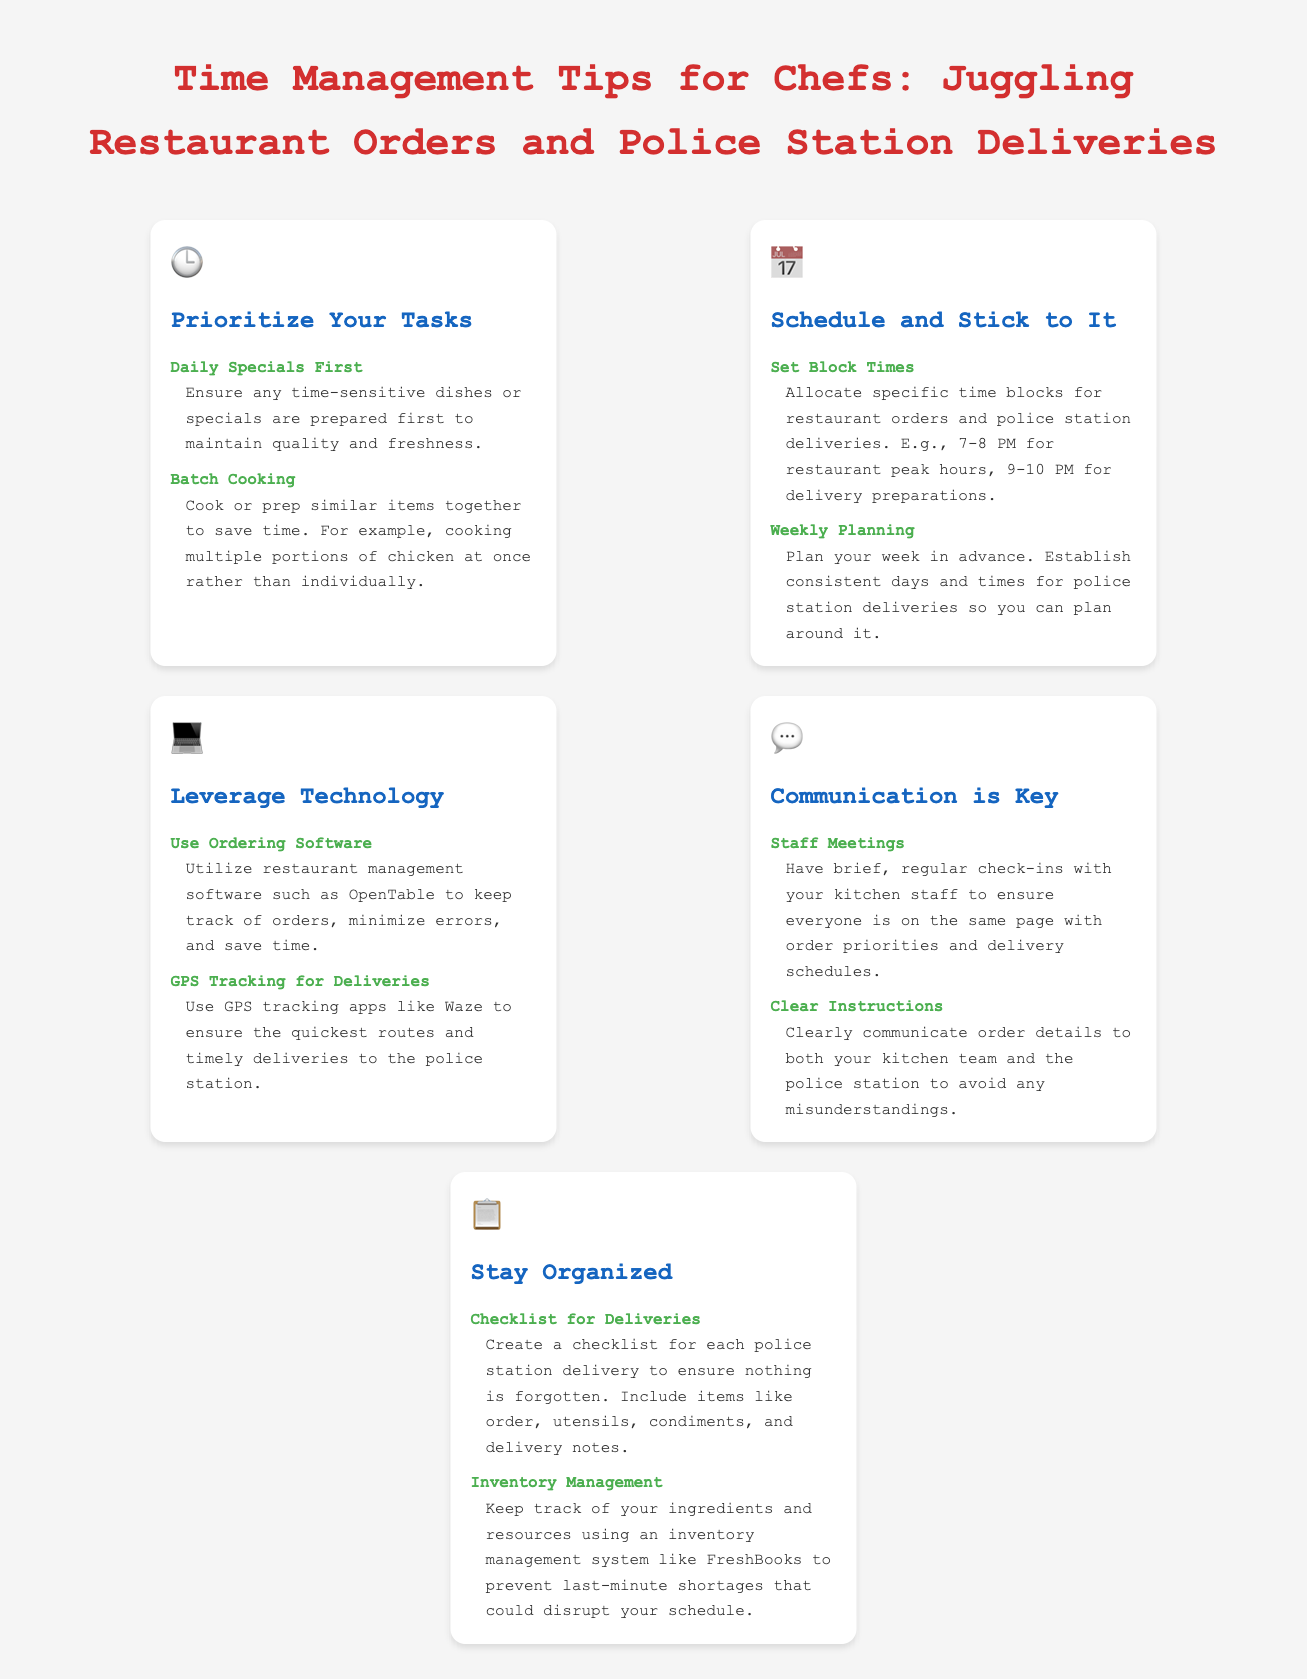what is the first priority for chefs when managing tasks? The first priority is to prepare any time-sensitive dishes or specials first to maintain quality and freshness.
Answer: Daily Specials First what technology should chefs use for managing orders? The document mentions utilizing restaurant management software for tracking orders.
Answer: Ordering Software what time block is suggested for restaurant peak hours? The suggested time block for restaurant peak hours is provided in the document.
Answer: 7-8 PM what should chefs create for each police station delivery? Chefs should create a checklist for each police station delivery to ensure nothing is forgotten.
Answer: Checklist for Deliveries how can chefs ensure timely deliveries to the police station? The document suggests using GPS tracking apps for ensuring quick routes.
Answer: GPS Tracking for Deliveries what is recommended to minimize errors in orders? The recommendation for minimizing errors in orders is clearly stating order details.
Answer: Clear Instructions what is the main goal of staff meetings according to the document? The goal of staff meetings is to ensure everyone is on the same page with order priorities.
Answer: Order Priorities how should chefs prepare similar items to save time? Chefs should cook or prep similar items together to save time.
Answer: Batch Cooking 